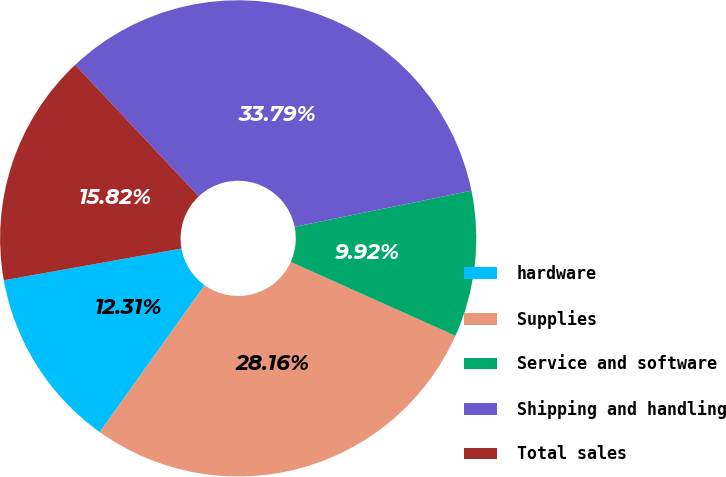Convert chart to OTSL. <chart><loc_0><loc_0><loc_500><loc_500><pie_chart><fcel>hardware<fcel>Supplies<fcel>Service and software<fcel>Shipping and handling<fcel>Total sales<nl><fcel>12.31%<fcel>28.16%<fcel>9.92%<fcel>33.79%<fcel>15.82%<nl></chart> 